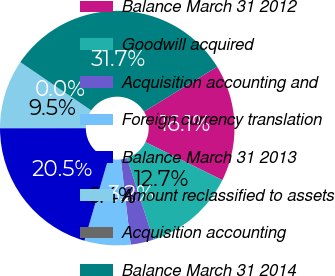<chart> <loc_0><loc_0><loc_500><loc_500><pie_chart><fcel>Balance March 31 2012<fcel>Goodwill acquired<fcel>Acquisition accounting and<fcel>Foreign currency translation<fcel>Balance March 31 2013<fcel>Amount reclassified to assets<fcel>Acquisition accounting<fcel>Balance March 31 2014<nl><fcel>16.08%<fcel>12.69%<fcel>3.17%<fcel>6.35%<fcel>20.47%<fcel>9.52%<fcel>0.0%<fcel>31.72%<nl></chart> 